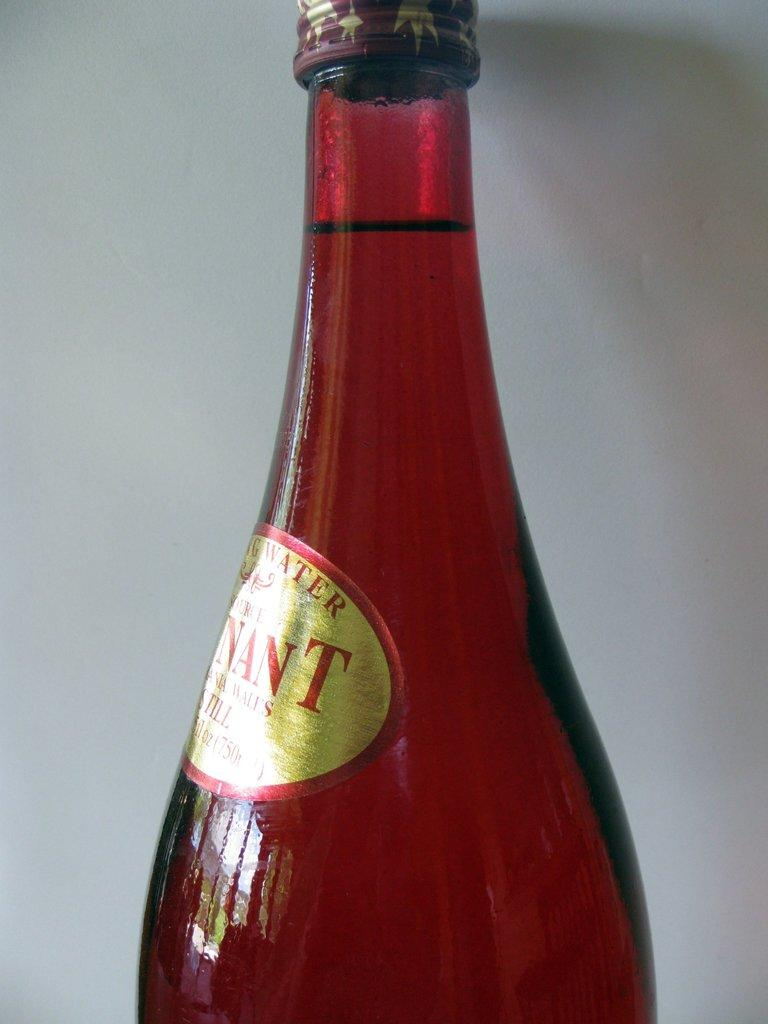What color is the bottle in the image? The bottle in the image is red. Is there anything on the bottle? Yes, there is a sticker on the bottle. How can the bottle be closed? The bottle has a lid. What color is the background of the image? The background of the image is white. What type of sweater is the bottle wearing in the image? The bottle is not wearing a sweater; it is an inanimate object and does not have clothing. 